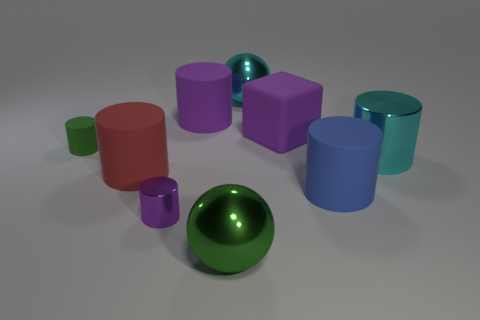The large metal ball to the right of the metal sphere in front of the large cube is what color?
Offer a terse response. Cyan. There is a metal sphere that is in front of the large metal ball behind the green metal sphere; are there any red matte cylinders that are on the right side of it?
Provide a short and direct response. No. There is a large cube that is made of the same material as the red thing; what is its color?
Give a very brief answer. Purple. What number of tiny green cylinders have the same material as the large green thing?
Offer a very short reply. 0. Are the large green ball and the green object that is behind the big red rubber object made of the same material?
Offer a very short reply. No. How many things are either big matte objects that are on the left side of the small metallic thing or large cyan metallic balls?
Your answer should be compact. 2. What is the size of the green thing that is on the left side of the big shiny sphere in front of the big rubber cylinder that is to the left of the purple metal thing?
Provide a succinct answer. Small. There is a small object that is the same color as the big rubber block; what material is it?
Give a very brief answer. Metal. Is there anything else that is the same shape as the green metallic thing?
Keep it short and to the point. Yes. There is a purple object that is to the right of the metal ball that is in front of the cyan metallic sphere; what is its size?
Offer a very short reply. Large. 